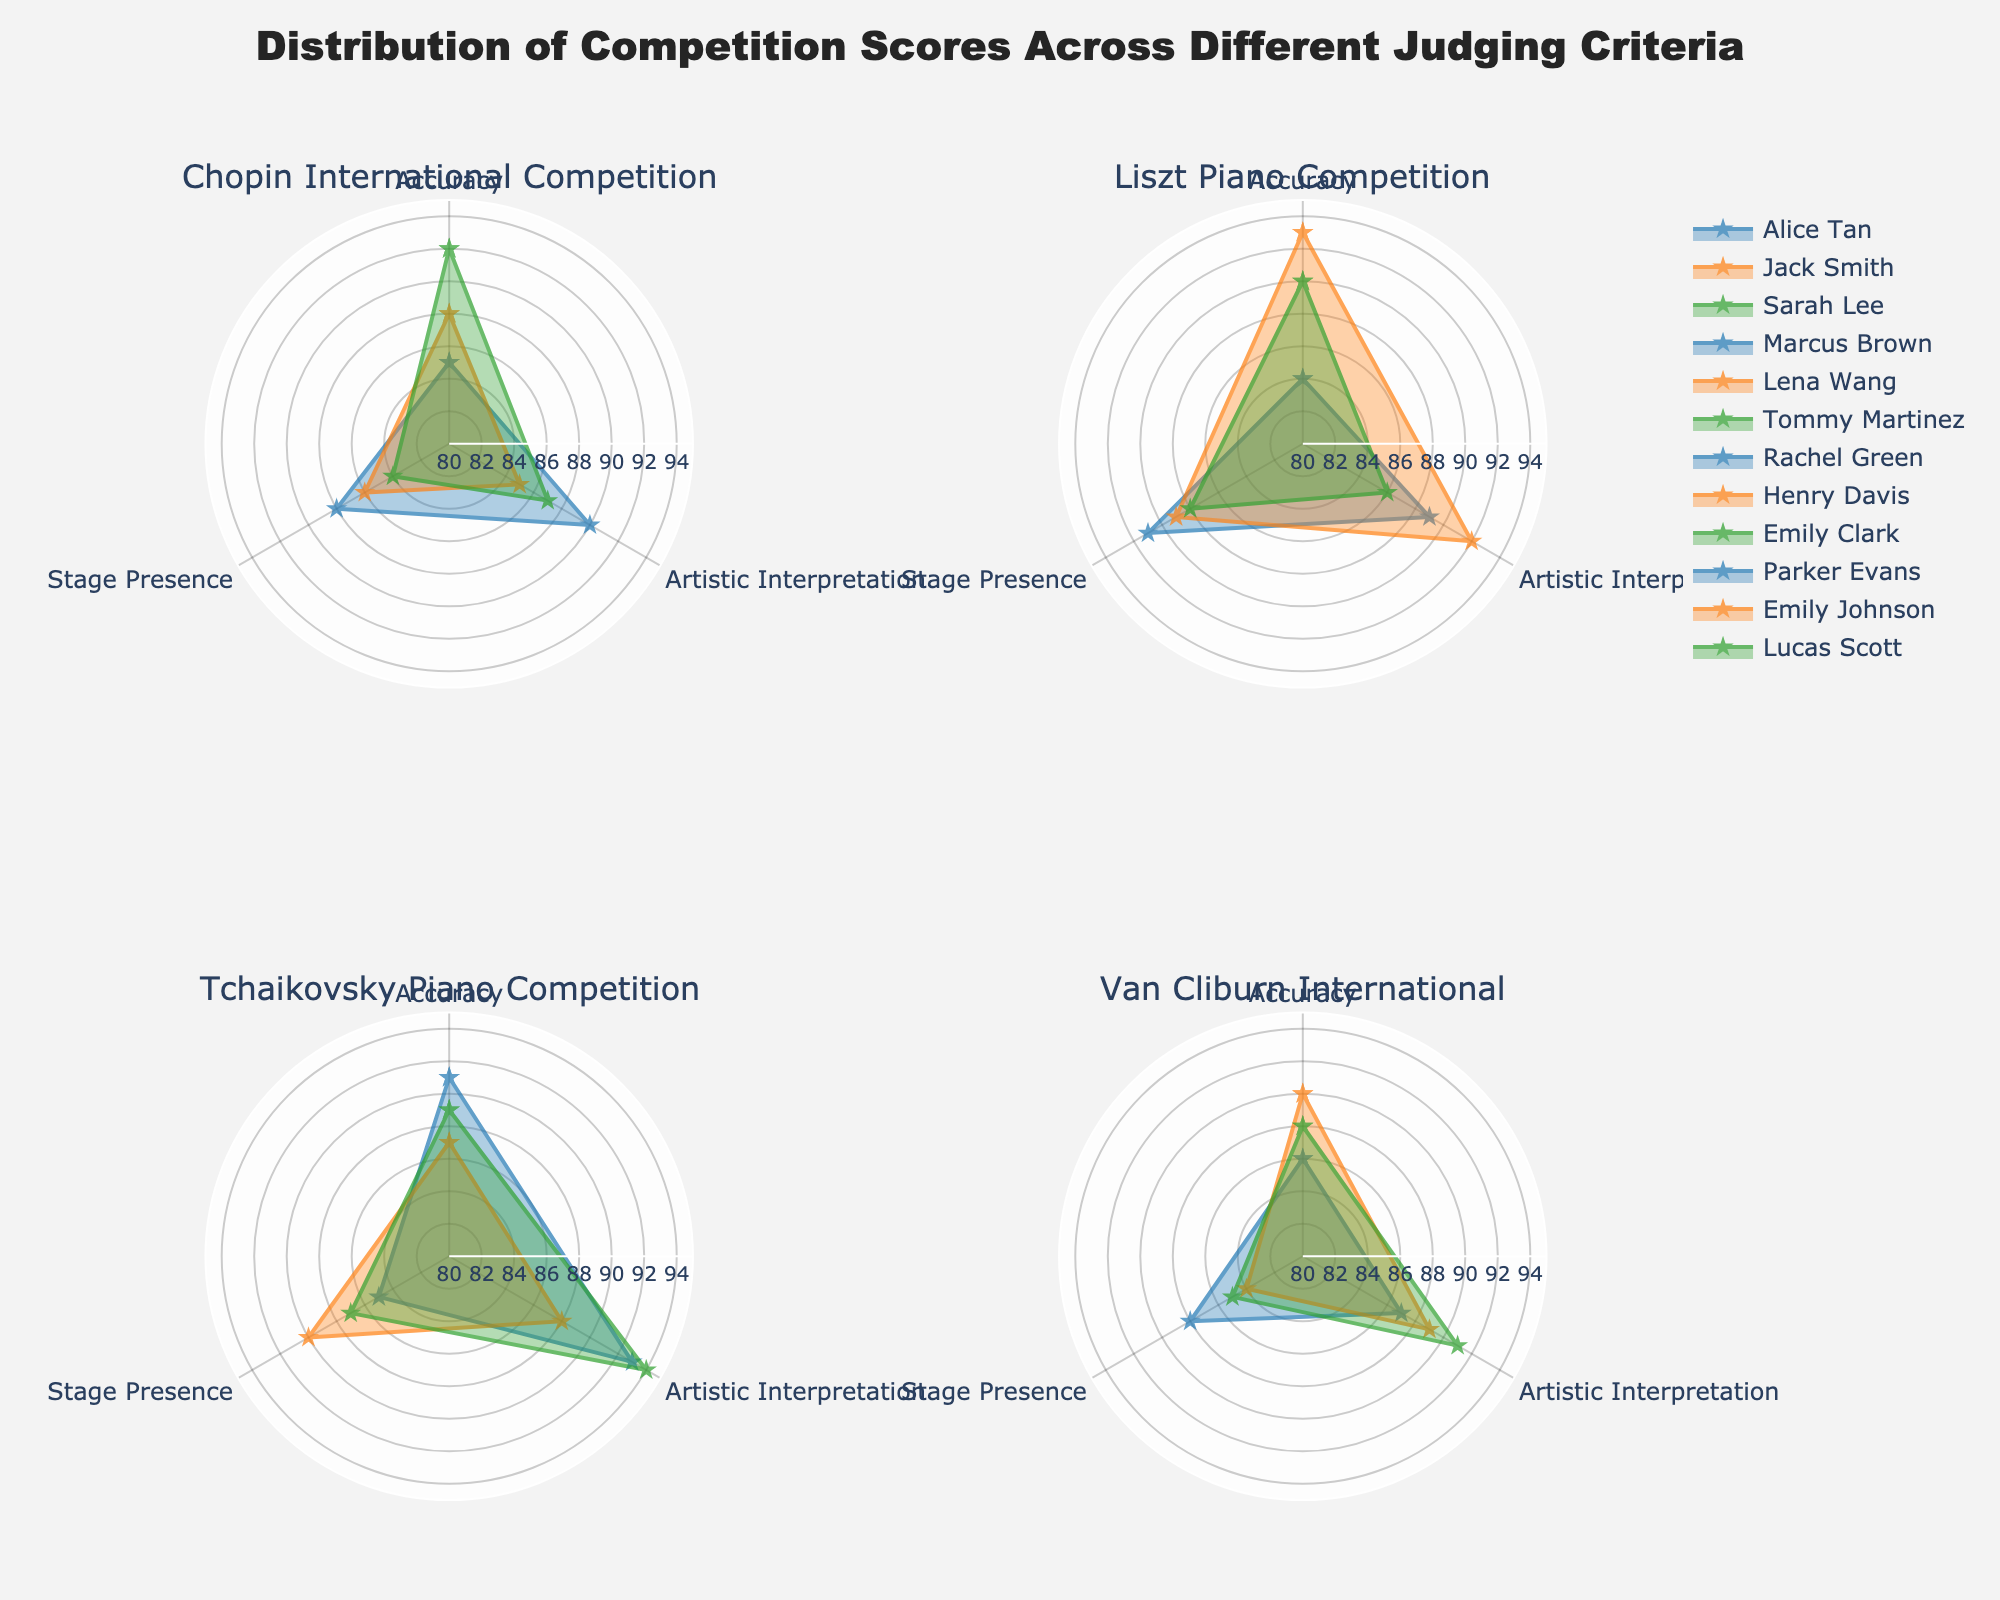What is the highest score for Artistic Interpretation in the Tchaikovsky Piano Competition? By examining the Tchaikovsky Piano Competition subplot in the radar chart, we see that Emily Clark's radar plot reaches the highest point for Artistic Interpretation.
Answer: 94 Which participant from the Chopin International Competition has the most balanced scores across all three criteria? A balanced score means the three criteria (Accuracy, Artistic Interpretation, and Stage Presence) are close to each other. Observing the radar plots, Jack Smith has approximately equal lengths for all three criteria.
Answer: Jack Smith Compare the Stage Presence scores of Ronny Brown from the Liszt Piano Competition and Henry Davis from the Tchaikovsky Piano Competition. Who has a higher score? By looking at the radar plots for both competitions, we see that Marcus Brown's Stage Presence score is 91 while Henry Davis has 90 in the Tchaikovsky Competition.
Answer: Marcus Brown Who has the lowest Accuracy score in the Chopin International Competition? Within the Chopin International Competition subplot, Alice Tan's radar plot has the shortest radius for Accuracy among the participants.
Answer: Alice Tan Calculate the average Artistic Interpretation score for the Van Cliburn International competition. We need the Artistic Interpretation scores of Parker Evans (87), Emily Johnson (89), and Lucas Scott (91). The average is (87 + 89 + 91) / 3 = 267 / 3 = 89.
Answer: 89 Which competition has the participant with the highest overall score? To find out the highest overall score for each competition, we examine the radar chart to see the outermost plot among all subplots: Lena Wang from the Liszt Competition stands out with consistently high scores in all criteria.
Answer: Liszt Piano Competition Identify the participant with the highest Accuracy score in the Van Cliburn International Competition. By inspecting the radar chart for the Van Cliburn subplot, Emily Johnson's plot corresponds to the longest Accuracy axis.
Answer: Emily Johnson 